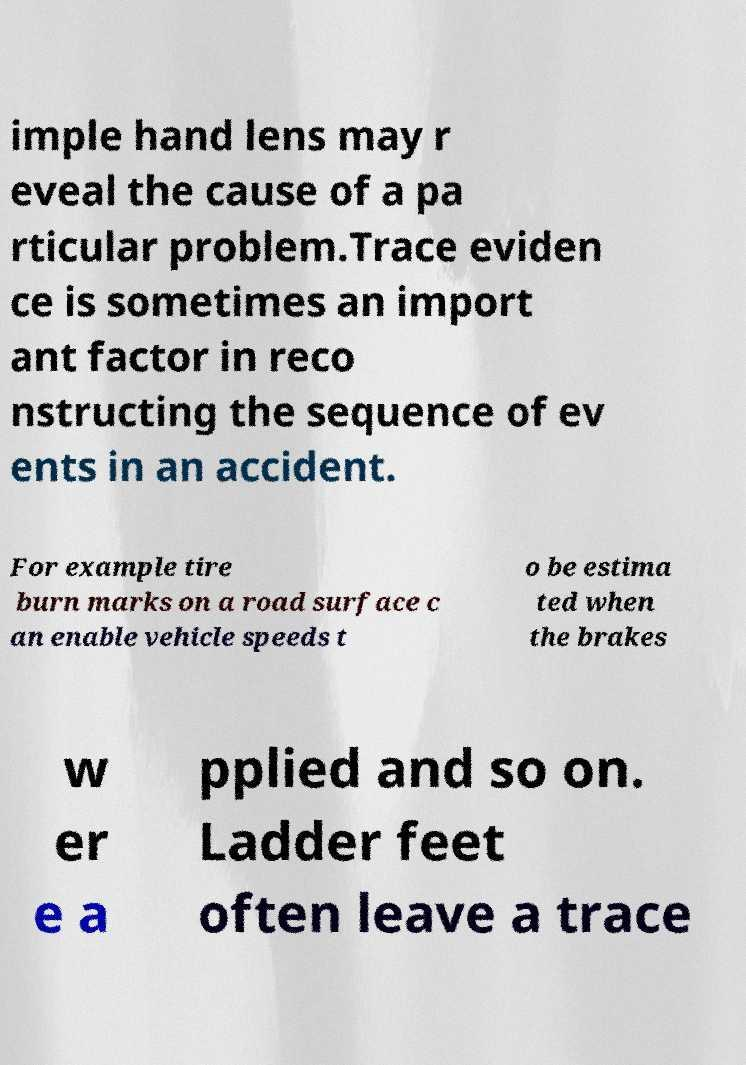Please read and relay the text visible in this image. What does it say? imple hand lens may r eveal the cause of a pa rticular problem.Trace eviden ce is sometimes an import ant factor in reco nstructing the sequence of ev ents in an accident. For example tire burn marks on a road surface c an enable vehicle speeds t o be estima ted when the brakes w er e a pplied and so on. Ladder feet often leave a trace 